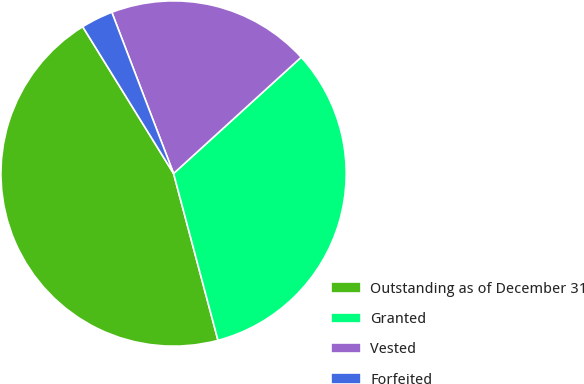Convert chart to OTSL. <chart><loc_0><loc_0><loc_500><loc_500><pie_chart><fcel>Outstanding as of December 31<fcel>Granted<fcel>Vested<fcel>Forfeited<nl><fcel>45.32%<fcel>32.62%<fcel>19.06%<fcel>3.0%<nl></chart> 